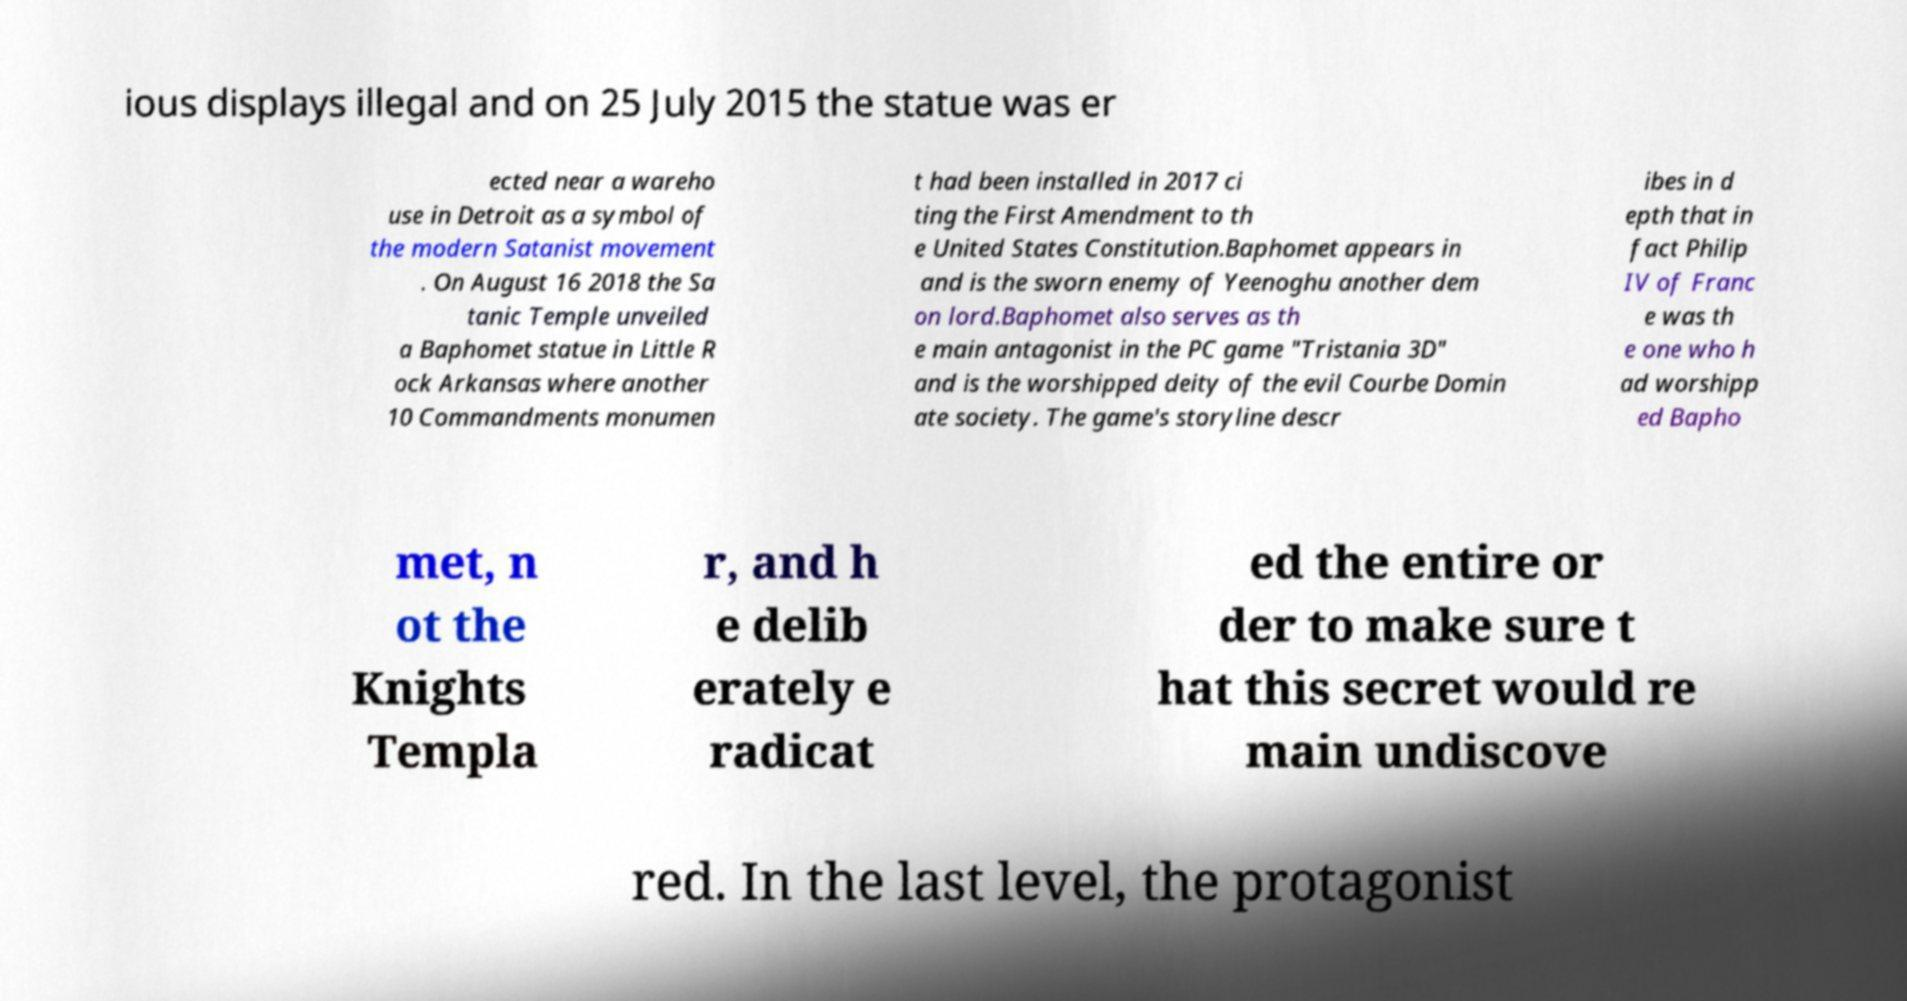Could you extract and type out the text from this image? ious displays illegal and on 25 July 2015 the statue was er ected near a wareho use in Detroit as a symbol of the modern Satanist movement . On August 16 2018 the Sa tanic Temple unveiled a Baphomet statue in Little R ock Arkansas where another 10 Commandments monumen t had been installed in 2017 ci ting the First Amendment to th e United States Constitution.Baphomet appears in and is the sworn enemy of Yeenoghu another dem on lord.Baphomet also serves as th e main antagonist in the PC game "Tristania 3D" and is the worshipped deity of the evil Courbe Domin ate society. The game's storyline descr ibes in d epth that in fact Philip IV of Franc e was th e one who h ad worshipp ed Bapho met, n ot the Knights Templa r, and h e delib erately e radicat ed the entire or der to make sure t hat this secret would re main undiscove red. In the last level, the protagonist 